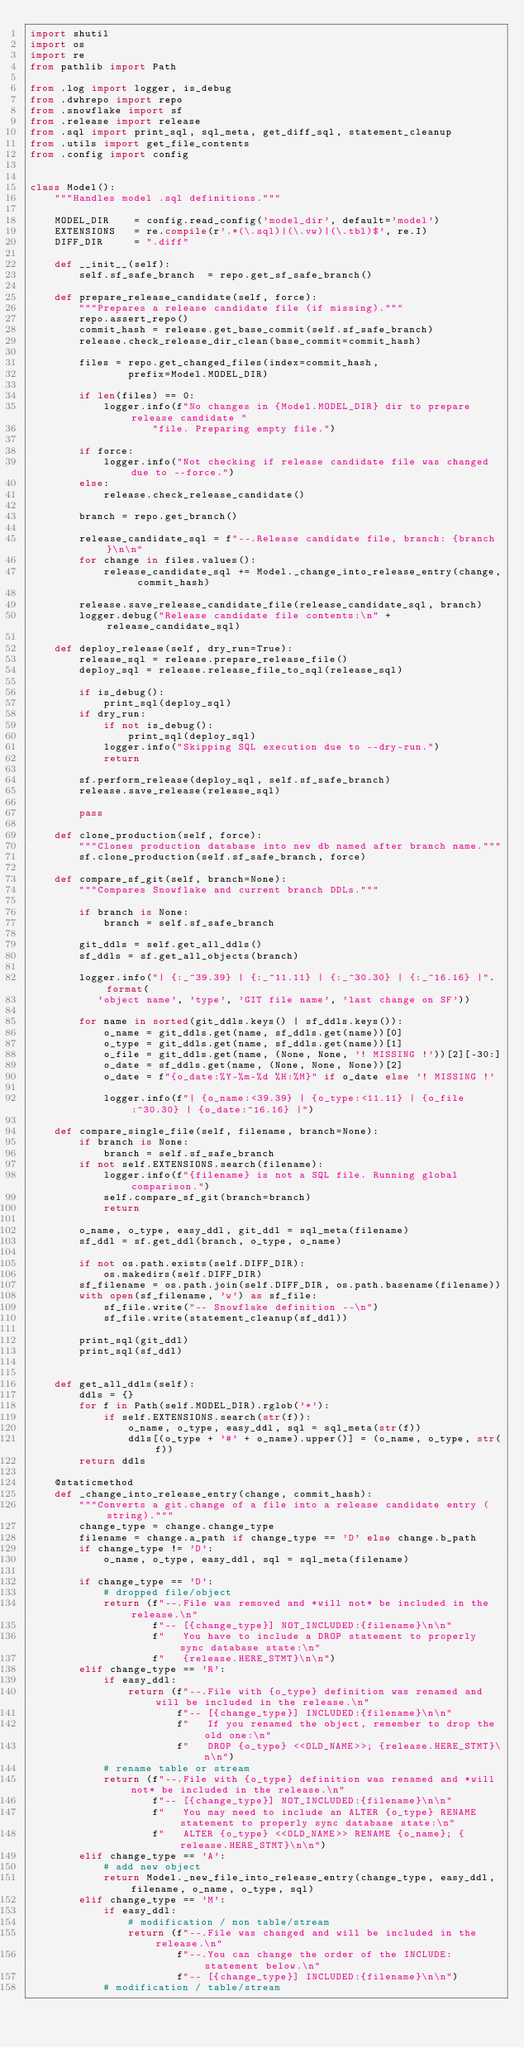<code> <loc_0><loc_0><loc_500><loc_500><_Python_>import shutil
import os
import re
from pathlib import Path

from .log import logger, is_debug
from .dwhrepo import repo
from .snowflake import sf
from .release import release
from .sql import print_sql, sql_meta, get_diff_sql, statement_cleanup
from .utils import get_file_contents
from .config import config


class Model():
    """Handles model .sql definitions."""

    MODEL_DIR    = config.read_config('model_dir', default='model')
    EXTENSIONS   = re.compile(r'.*(\.sql)|(\.vw)|(\.tbl)$', re.I)
    DIFF_DIR     = ".diff"

    def __init__(self):
        self.sf_safe_branch  = repo.get_sf_safe_branch()

    def prepare_release_candidate(self, force):
        """Prepares a release candidate file (if missing)."""
        repo.assert_repo()
        commit_hash = release.get_base_commit(self.sf_safe_branch)
        release.check_release_dir_clean(base_commit=commit_hash)

        files = repo.get_changed_files(index=commit_hash,
                prefix=Model.MODEL_DIR)

        if len(files) == 0:
            logger.info(f"No changes in {Model.MODEL_DIR} dir to prepare release candidate "
                    "file. Preparing empty file.")

        if force:
            logger.info("Not checking if release candidate file was changed due to --force.")
        else:
            release.check_release_candidate()

        branch = repo.get_branch()

        release_candidate_sql = f"--.Release candidate file, branch: {branch}\n\n"
        for change in files.values():
            release_candidate_sql += Model._change_into_release_entry(change, commit_hash)

        release.save_release_candidate_file(release_candidate_sql, branch)
        logger.debug("Release candidate file contents:\n" + release_candidate_sql)

    def deploy_release(self, dry_run=True):
        release_sql = release.prepare_release_file()
        deploy_sql = release.release_file_to_sql(release_sql)

        if is_debug():
            print_sql(deploy_sql)
        if dry_run:
            if not is_debug():
                print_sql(deploy_sql)
            logger.info("Skipping SQL execution due to --dry-run.")
            return

        sf.perform_release(deploy_sql, self.sf_safe_branch)
        release.save_release(release_sql)

        pass
        
    def clone_production(self, force):
        """Clones production database into new db named after branch name."""
        sf.clone_production(self.sf_safe_branch, force)

    def compare_sf_git(self, branch=None):
        """Compares Snowflake and current branch DDLs."""

        if branch is None:
            branch = self.sf_safe_branch

        git_ddls = self.get_all_ddls()
        sf_ddls = sf.get_all_objects(branch)

        logger.info("| {:_^39.39} | {:_^11.11} | {:_^30.30} | {:_^16.16} |".format(
           'object name', 'type', 'GIT file name', 'last change on SF'))   

        for name in sorted(git_ddls.keys() | sf_ddls.keys()):
            o_name = git_ddls.get(name, sf_ddls.get(name))[0]
            o_type = git_ddls.get(name, sf_ddls.get(name))[1]
            o_file = git_ddls.get(name, (None, None, '! MISSING !'))[2][-30:]
            o_date = sf_ddls.get(name, (None, None, None))[2]
            o_date = f"{o_date:%Y-%m-%d %H:%M}" if o_date else '! MISSING !'

            logger.info(f"| {o_name:<39.39} | {o_type:<11.11} | {o_file:^30.30} | {o_date:^16.16} |")
    
    def compare_single_file(self, filename, branch=None):
        if branch is None:
            branch = self.sf_safe_branch
        if not self.EXTENSIONS.search(filename):
            logger.info(f"{filename} is not a SQL file. Running global comparison.")
            self.compare_sf_git(branch=branch)
            return
        
        o_name, o_type, easy_ddl, git_ddl = sql_meta(filename)
        sf_ddl = sf.get_ddl(branch, o_type, o_name)

        if not os.path.exists(self.DIFF_DIR):
            os.makedirs(self.DIFF_DIR)
        sf_filename = os.path.join(self.DIFF_DIR, os.path.basename(filename))
        with open(sf_filename, 'w') as sf_file:
            sf_file.write("-- Snowflake definition --\n")
            sf_file.write(statement_cleanup(sf_ddl))

        print_sql(git_ddl)
        print_sql(sf_ddl)


    def get_all_ddls(self):
        ddls = {}
        for f in Path(self.MODEL_DIR).rglob('*'):
            if self.EXTENSIONS.search(str(f)):
                o_name, o_type, easy_ddl, sql = sql_meta(str(f))
                ddls[(o_type + '#' + o_name).upper()] = (o_name, o_type, str(f))
        return ddls

    @staticmethod
    def _change_into_release_entry(change, commit_hash):
        """Converts a git.change of a file into a release candidate entry (string)."""
        change_type = change.change_type
        filename = change.a_path if change_type == 'D' else change.b_path
        if change_type != 'D':
            o_name, o_type, easy_ddl, sql = sql_meta(filename)

        if change_type == 'D':
            # dropped file/object
            return (f"--.File was removed and *will not* be included in the release.\n"
                    f"-- [{change_type}] NOT_INCLUDED:{filename}\n\n"
                    f"   You have to include a DROP statement to properly sync database state:\n"
                    f"   {release.HERE_STMT}\n\n")
        elif change_type == 'R':
            if easy_ddl:
                return (f"--.File with {o_type} definition was renamed and will be included in the release.\n"
                        f"-- [{change_type}] INCLUDED:{filename}\n\n"
                        f"   If you renamed the object, remember to drop the old one:\n"
                        f"   DROP {o_type} <<OLD_NAME>>; {release.HERE_STMT}\n\n")
            # rename table or stream
            return (f"--.File with {o_type} definition was renamed and *will not* be included in the release.\n"
                    f"-- [{change_type}] NOT_INCLUDED:{filename}\n\n"
                    f"   You may need to include an ALTER {o_type} RENAME statement to properly sync database state:\n"
                    f"   ALTER {o_type} <<OLD_NAME>> RENAME {o_name}; {release.HERE_STMT}\n\n")
        elif change_type == 'A':
            # add new object
            return Model._new_file_into_release_entry(change_type, easy_ddl, filename, o_name, o_type, sql)
        elif change_type == 'M':
            if easy_ddl:
                # modification / non table/stream
                return (f"--.File was changed and will be included in the release.\n"
                        f"--.You can change the order of the INCLUDE: statement below.\n"
                        f"-- [{change_type}] INCLUDED:{filename}\n\n")
            # modification / table/stream</code> 